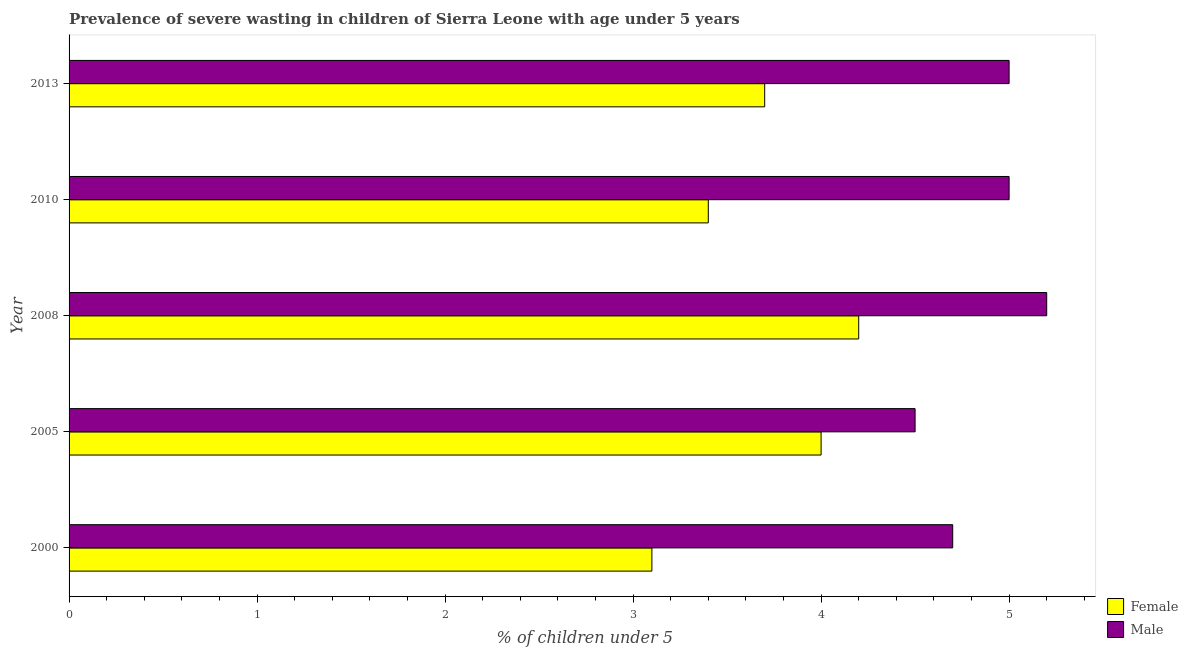How many different coloured bars are there?
Your response must be concise. 2. What is the label of the 5th group of bars from the top?
Offer a very short reply. 2000. Across all years, what is the maximum percentage of undernourished female children?
Offer a very short reply. 4.2. Across all years, what is the minimum percentage of undernourished female children?
Give a very brief answer. 3.1. In which year was the percentage of undernourished female children minimum?
Offer a very short reply. 2000. What is the total percentage of undernourished female children in the graph?
Your response must be concise. 18.4. What is the difference between the percentage of undernourished male children in 2000 and the percentage of undernourished female children in 2013?
Your answer should be very brief. 1. What is the average percentage of undernourished male children per year?
Provide a succinct answer. 4.88. In the year 2008, what is the difference between the percentage of undernourished male children and percentage of undernourished female children?
Keep it short and to the point. 1. In how many years, is the percentage of undernourished male children greater than 0.6000000000000001 %?
Keep it short and to the point. 5. What is the ratio of the percentage of undernourished male children in 2005 to that in 2010?
Give a very brief answer. 0.9. Is the percentage of undernourished male children in 2000 less than that in 2010?
Keep it short and to the point. Yes. In how many years, is the percentage of undernourished male children greater than the average percentage of undernourished male children taken over all years?
Give a very brief answer. 3. Is the sum of the percentage of undernourished female children in 2000 and 2005 greater than the maximum percentage of undernourished male children across all years?
Ensure brevity in your answer.  Yes. What does the 2nd bar from the bottom in 2000 represents?
Give a very brief answer. Male. What is the difference between two consecutive major ticks on the X-axis?
Provide a succinct answer. 1. Are the values on the major ticks of X-axis written in scientific E-notation?
Offer a terse response. No. Where does the legend appear in the graph?
Your answer should be very brief. Bottom right. How many legend labels are there?
Offer a terse response. 2. How are the legend labels stacked?
Keep it short and to the point. Vertical. What is the title of the graph?
Make the answer very short. Prevalence of severe wasting in children of Sierra Leone with age under 5 years. What is the label or title of the X-axis?
Your answer should be compact.  % of children under 5. What is the  % of children under 5 of Female in 2000?
Offer a terse response. 3.1. What is the  % of children under 5 in Male in 2000?
Provide a short and direct response. 4.7. What is the  % of children under 5 in Female in 2005?
Give a very brief answer. 4. What is the  % of children under 5 in Male in 2005?
Your response must be concise. 4.5. What is the  % of children under 5 of Female in 2008?
Provide a short and direct response. 4.2. What is the  % of children under 5 in Male in 2008?
Keep it short and to the point. 5.2. What is the  % of children under 5 in Female in 2010?
Your answer should be compact. 3.4. What is the  % of children under 5 of Female in 2013?
Keep it short and to the point. 3.7. Across all years, what is the maximum  % of children under 5 in Female?
Keep it short and to the point. 4.2. Across all years, what is the maximum  % of children under 5 of Male?
Offer a terse response. 5.2. Across all years, what is the minimum  % of children under 5 in Female?
Offer a very short reply. 3.1. Across all years, what is the minimum  % of children under 5 in Male?
Provide a short and direct response. 4.5. What is the total  % of children under 5 of Male in the graph?
Your response must be concise. 24.4. What is the difference between the  % of children under 5 of Female in 2000 and that in 2005?
Your response must be concise. -0.9. What is the difference between the  % of children under 5 of Male in 2000 and that in 2008?
Your answer should be compact. -0.5. What is the difference between the  % of children under 5 of Female in 2000 and that in 2010?
Your answer should be compact. -0.3. What is the difference between the  % of children under 5 in Male in 2000 and that in 2010?
Your response must be concise. -0.3. What is the difference between the  % of children under 5 in Male in 2000 and that in 2013?
Offer a terse response. -0.3. What is the difference between the  % of children under 5 of Female in 2005 and that in 2008?
Keep it short and to the point. -0.2. What is the difference between the  % of children under 5 in Male in 2005 and that in 2008?
Give a very brief answer. -0.7. What is the difference between the  % of children under 5 of Female in 2005 and that in 2010?
Make the answer very short. 0.6. What is the difference between the  % of children under 5 in Male in 2005 and that in 2010?
Offer a very short reply. -0.5. What is the difference between the  % of children under 5 of Female in 2008 and that in 2010?
Ensure brevity in your answer.  0.8. What is the difference between the  % of children under 5 of Male in 2008 and that in 2010?
Offer a very short reply. 0.2. What is the difference between the  % of children under 5 of Female in 2008 and that in 2013?
Your response must be concise. 0.5. What is the difference between the  % of children under 5 of Male in 2008 and that in 2013?
Keep it short and to the point. 0.2. What is the difference between the  % of children under 5 of Female in 2010 and that in 2013?
Make the answer very short. -0.3. What is the difference between the  % of children under 5 of Male in 2010 and that in 2013?
Offer a very short reply. 0. What is the difference between the  % of children under 5 of Female in 2000 and the  % of children under 5 of Male in 2005?
Offer a terse response. -1.4. What is the difference between the  % of children under 5 of Female in 2000 and the  % of children under 5 of Male in 2008?
Offer a very short reply. -2.1. What is the difference between the  % of children under 5 in Female in 2000 and the  % of children under 5 in Male in 2010?
Give a very brief answer. -1.9. What is the difference between the  % of children under 5 in Female in 2000 and the  % of children under 5 in Male in 2013?
Give a very brief answer. -1.9. What is the difference between the  % of children under 5 of Female in 2005 and the  % of children under 5 of Male in 2008?
Provide a short and direct response. -1.2. What is the difference between the  % of children under 5 in Female in 2005 and the  % of children under 5 in Male in 2013?
Your answer should be compact. -1. What is the difference between the  % of children under 5 in Female in 2008 and the  % of children under 5 in Male in 2010?
Your answer should be compact. -0.8. What is the average  % of children under 5 in Female per year?
Provide a short and direct response. 3.68. What is the average  % of children under 5 of Male per year?
Ensure brevity in your answer.  4.88. In the year 2005, what is the difference between the  % of children under 5 of Female and  % of children under 5 of Male?
Give a very brief answer. -0.5. In the year 2008, what is the difference between the  % of children under 5 in Female and  % of children under 5 in Male?
Your response must be concise. -1. What is the ratio of the  % of children under 5 of Female in 2000 to that in 2005?
Provide a succinct answer. 0.78. What is the ratio of the  % of children under 5 of Male in 2000 to that in 2005?
Your answer should be very brief. 1.04. What is the ratio of the  % of children under 5 of Female in 2000 to that in 2008?
Make the answer very short. 0.74. What is the ratio of the  % of children under 5 of Male in 2000 to that in 2008?
Your response must be concise. 0.9. What is the ratio of the  % of children under 5 of Female in 2000 to that in 2010?
Provide a succinct answer. 0.91. What is the ratio of the  % of children under 5 in Female in 2000 to that in 2013?
Provide a succinct answer. 0.84. What is the ratio of the  % of children under 5 in Female in 2005 to that in 2008?
Offer a very short reply. 0.95. What is the ratio of the  % of children under 5 in Male in 2005 to that in 2008?
Keep it short and to the point. 0.87. What is the ratio of the  % of children under 5 of Female in 2005 to that in 2010?
Provide a succinct answer. 1.18. What is the ratio of the  % of children under 5 of Male in 2005 to that in 2010?
Offer a terse response. 0.9. What is the ratio of the  % of children under 5 in Female in 2005 to that in 2013?
Your answer should be very brief. 1.08. What is the ratio of the  % of children under 5 of Female in 2008 to that in 2010?
Ensure brevity in your answer.  1.24. What is the ratio of the  % of children under 5 in Female in 2008 to that in 2013?
Give a very brief answer. 1.14. What is the ratio of the  % of children under 5 in Male in 2008 to that in 2013?
Provide a short and direct response. 1.04. What is the ratio of the  % of children under 5 in Female in 2010 to that in 2013?
Provide a succinct answer. 0.92. What is the ratio of the  % of children under 5 of Male in 2010 to that in 2013?
Offer a very short reply. 1. 